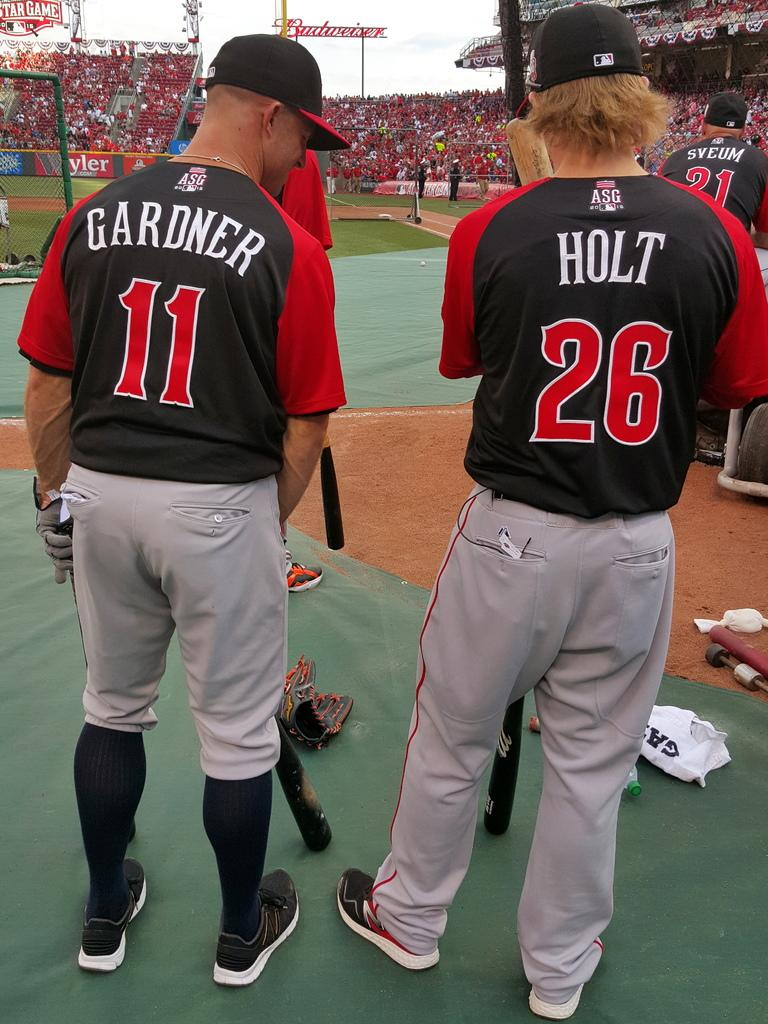<image>
Summarize the visual content of the image. ASG baseball players number 11 and 26 wearing red and black jersey tops 